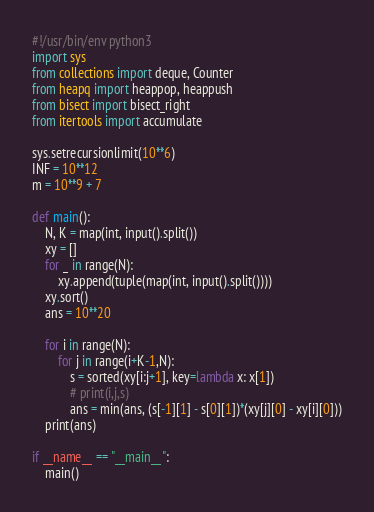Convert code to text. <code><loc_0><loc_0><loc_500><loc_500><_Python_>#!/usr/bin/env python3
import sys
from collections import deque, Counter
from heapq import heappop, heappush
from bisect import bisect_right
from itertools import accumulate

sys.setrecursionlimit(10**6)
INF = 10**12
m = 10**9 + 7

def main():
    N, K = map(int, input().split())
    xy = []
    for _ in range(N):
        xy.append(tuple(map(int, input().split())))
    xy.sort()
    ans = 10**20
    
    for i in range(N):
        for j in range(i+K-1,N):
            s = sorted(xy[i:j+1], key=lambda x: x[1])
            # print(i,j,s)
            ans = min(ans, (s[-1][1] - s[0][1])*(xy[j][0] - xy[i][0]))
    print(ans)

if __name__ == "__main__":
    main()
</code> 